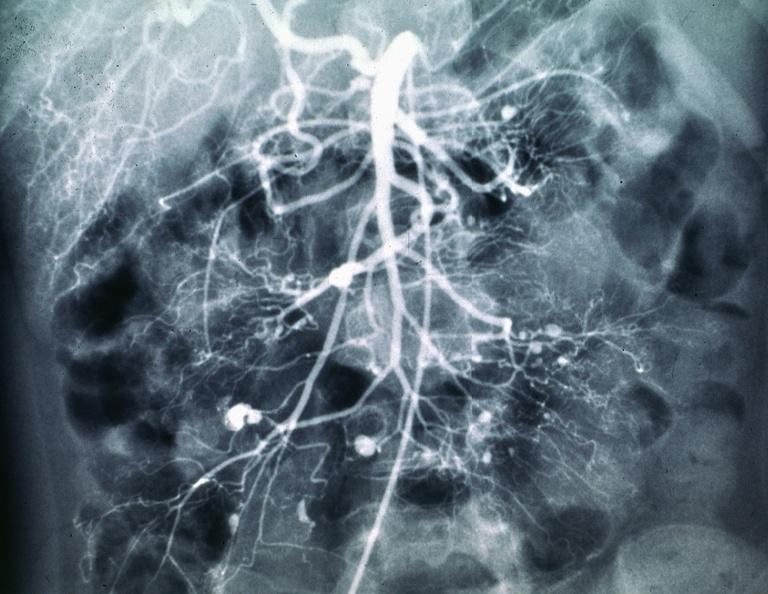what does this image show?
Answer the question using a single word or phrase. Polyarteritis nodosa mesentaric artery arteriogram 